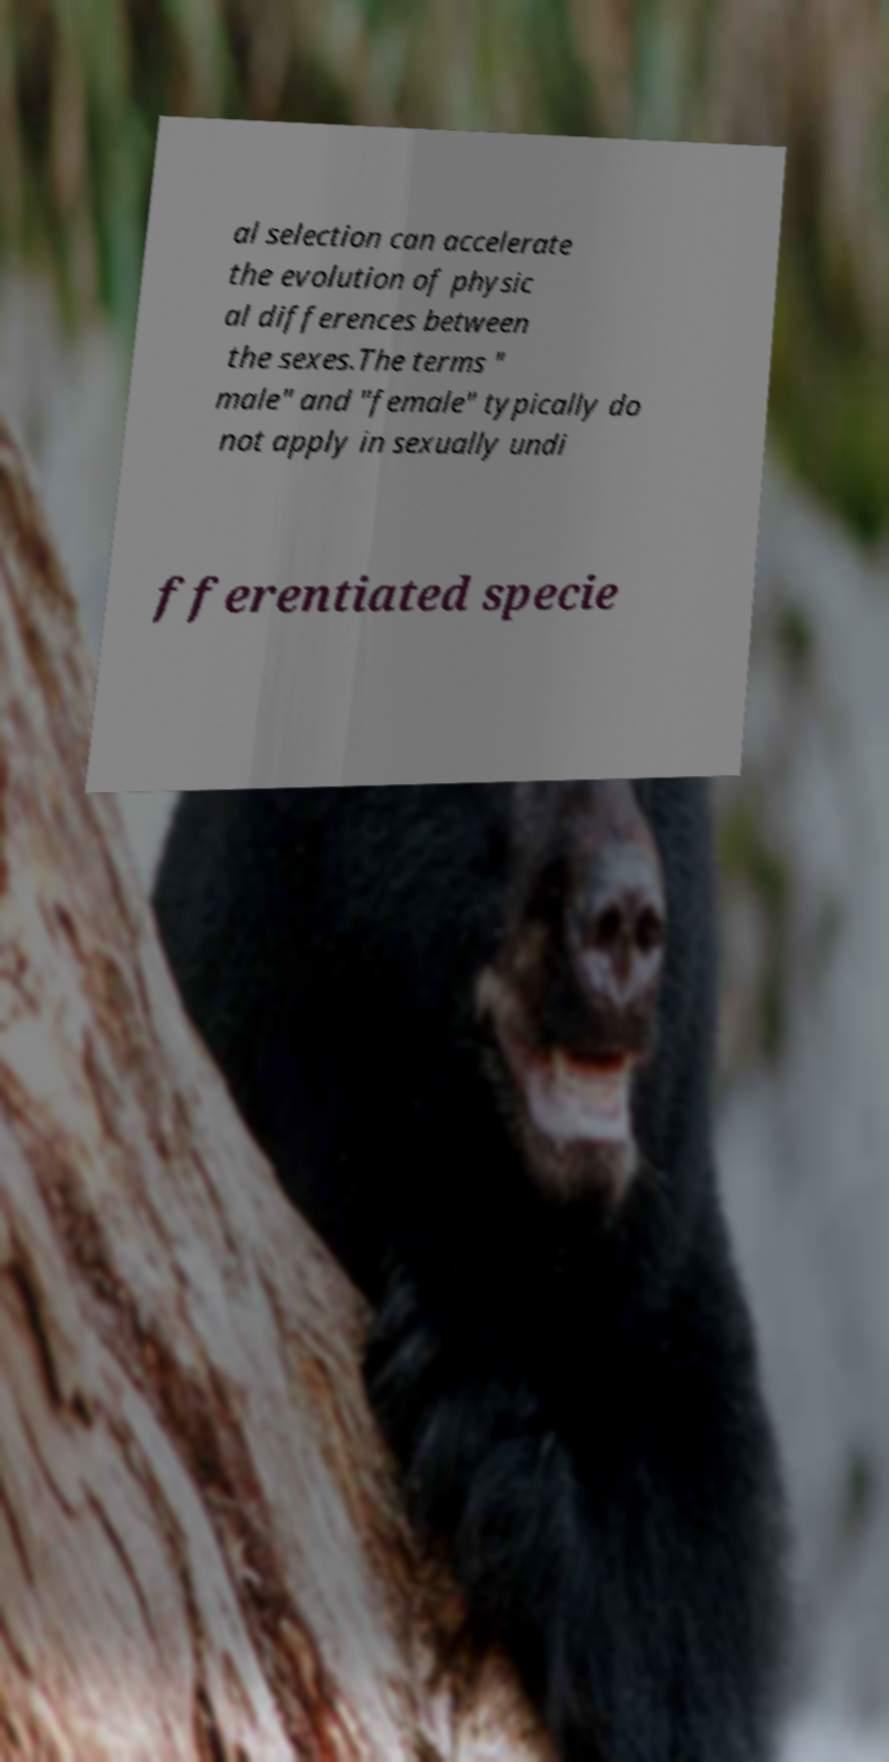Could you extract and type out the text from this image? al selection can accelerate the evolution of physic al differences between the sexes.The terms " male" and "female" typically do not apply in sexually undi fferentiated specie 